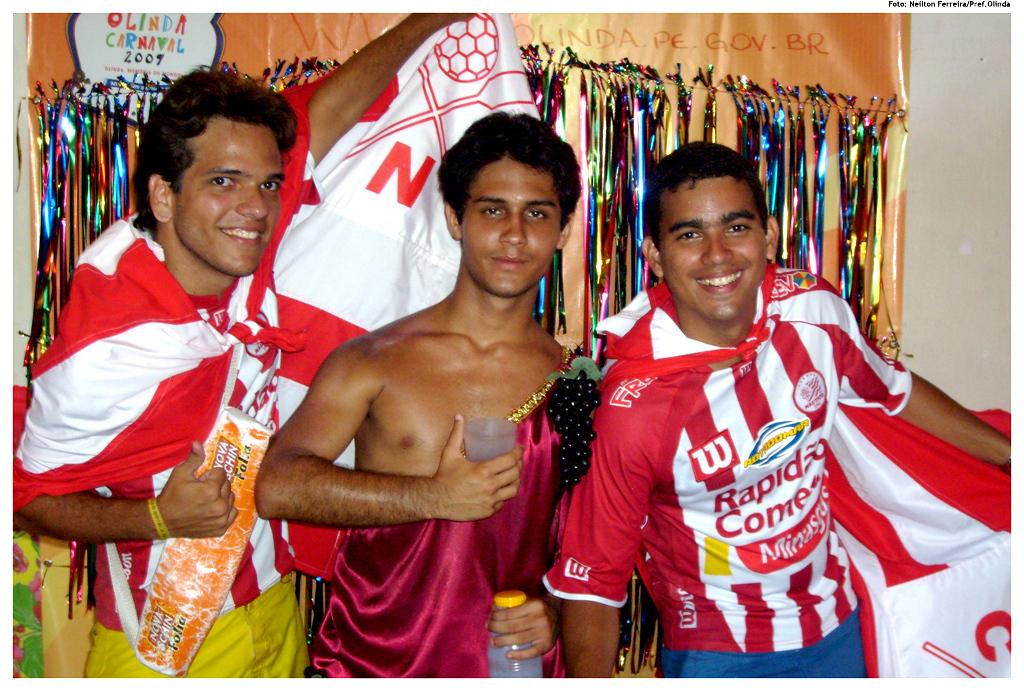<image>
Create a compact narrative representing the image presented. In 2009 these people went to the Olinda Carnaval. 